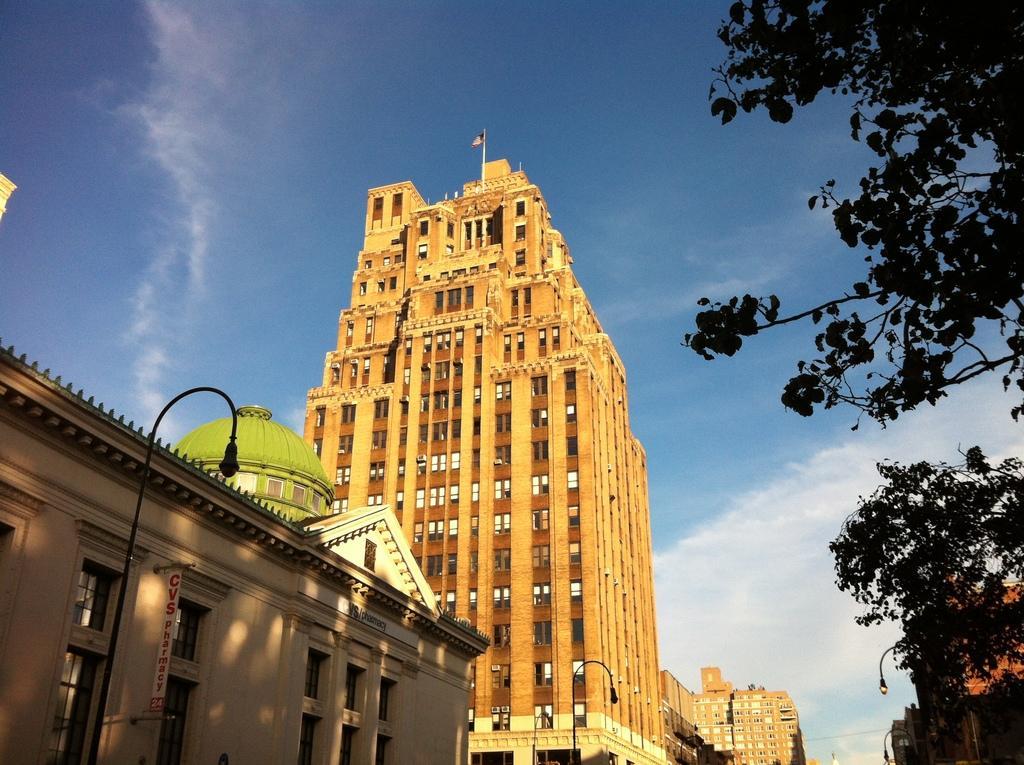In one or two sentences, can you explain what this image depicts? In this image there are buildings, in the right side there is a tree, in the background there is a blue sky. 